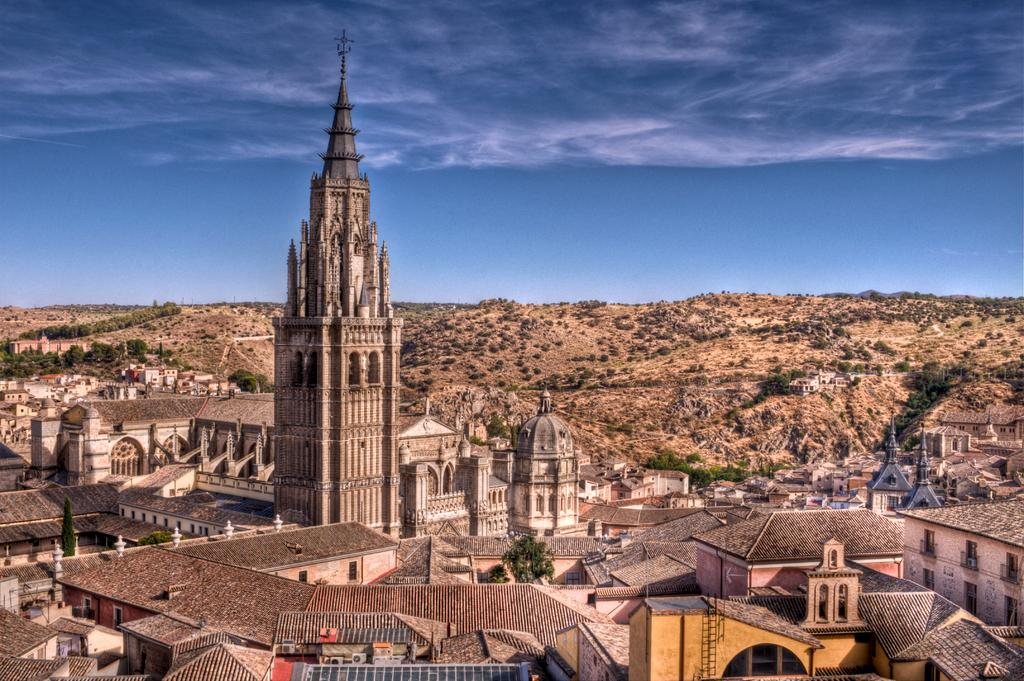What types of structures are visible in the image? There are buildings in the image. What type of vegetation can be seen in the image? There are trees and plants in the image. What else can be seen in the image besides buildings and vegetation? There are other objects in the image. What is visible in the background of the image? There are trees, plants, and other objects in the background of the image. What is visible at the top of the image? The sky is visible at the top of the image. What month is it in the image? The month cannot be determined from the image, as it does not contain any information about the time of year. Can you see a squirrel climbing one of the trees in the image? There is no squirrel visible in the image. 